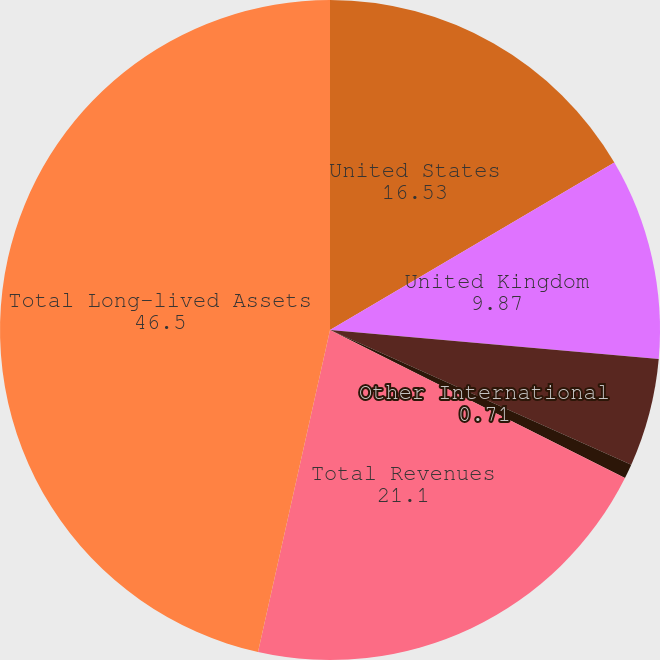Convert chart. <chart><loc_0><loc_0><loc_500><loc_500><pie_chart><fcel>United States<fcel>United Kingdom<fcel>Canada<fcel>Other International<fcel>Total Revenues<fcel>Total Long-lived Assets<nl><fcel>16.53%<fcel>9.87%<fcel>5.29%<fcel>0.71%<fcel>21.1%<fcel>46.5%<nl></chart> 